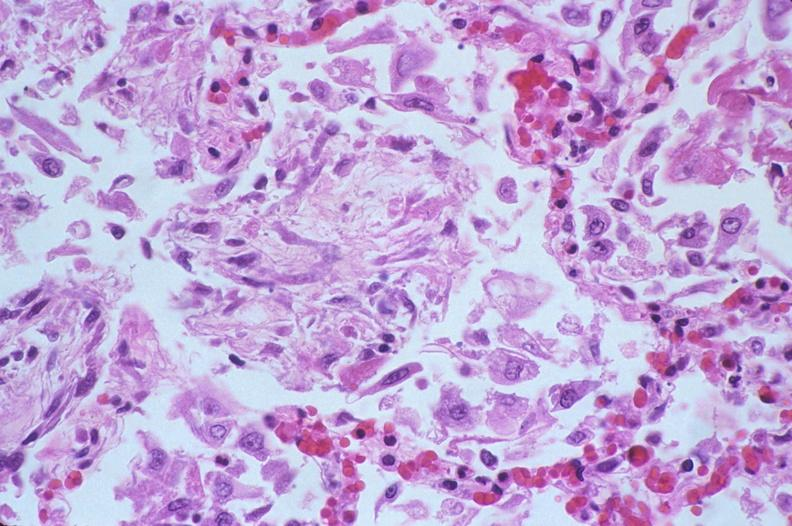s respiratory present?
Answer the question using a single word or phrase. Yes 